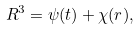Convert formula to latex. <formula><loc_0><loc_0><loc_500><loc_500>R ^ { 3 } = \psi ( t ) + \chi ( r ) ,</formula> 